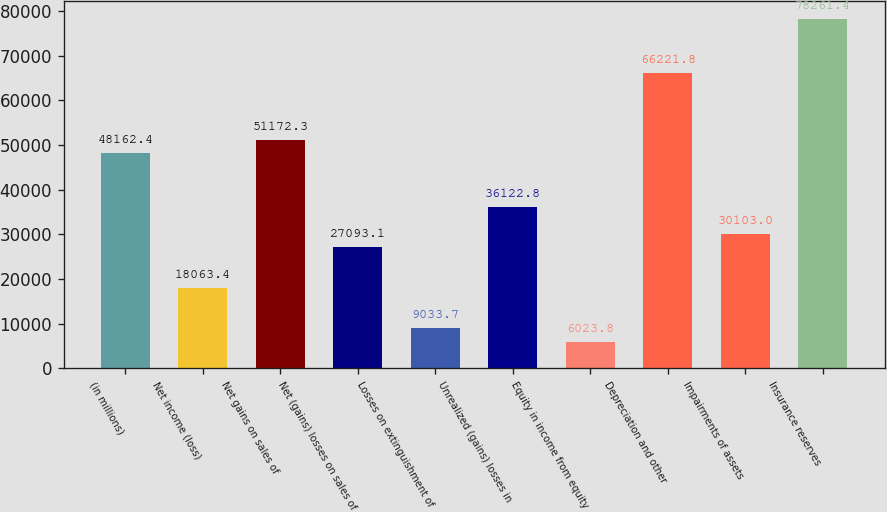Convert chart. <chart><loc_0><loc_0><loc_500><loc_500><bar_chart><fcel>(in millions)<fcel>Net income (loss)<fcel>Net gains on sales of<fcel>Net (gains) losses on sales of<fcel>Losses on extinguishment of<fcel>Unrealized (gains) losses in<fcel>Equity in income from equity<fcel>Depreciation and other<fcel>Impairments of assets<fcel>Insurance reserves<nl><fcel>48162.4<fcel>18063.4<fcel>51172.3<fcel>27093.1<fcel>9033.7<fcel>36122.8<fcel>6023.8<fcel>66221.8<fcel>30103<fcel>78261.4<nl></chart> 